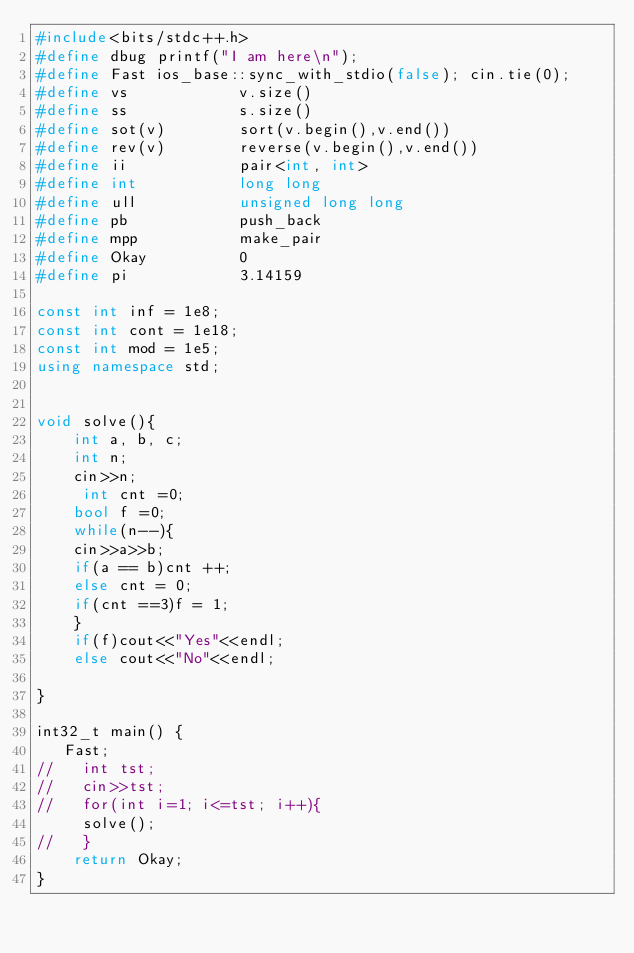<code> <loc_0><loc_0><loc_500><loc_500><_C++_>#include<bits/stdc++.h>
#define dbug printf("I am here\n");
#define Fast ios_base::sync_with_stdio(false); cin.tie(0);
#define vs            v.size()
#define ss            s.size()
#define sot(v)        sort(v.begin(),v.end())
#define rev(v)        reverse(v.begin(),v.end())
#define ii            pair<int, int>
#define int           long long
#define ull           unsigned long long
#define pb            push_back
#define mpp           make_pair
#define Okay          0
#define pi            3.14159

const int inf = 1e8;
const int cont = 1e18;
const int mod = 1e5;
using namespace std;


void solve(){
    int a, b, c;
    int n;
    cin>>n;
     int cnt =0;
    bool f =0;
    while(n--){
    cin>>a>>b;
    if(a == b)cnt ++;
    else cnt = 0;
    if(cnt ==3)f = 1;
    }
    if(f)cout<<"Yes"<<endl;
    else cout<<"No"<<endl;

}

int32_t main() {
   Fast;
//   int tst;
//   cin>>tst;
//   for(int i=1; i<=tst; i++){
     solve();
//   }
    return Okay;
}

</code> 